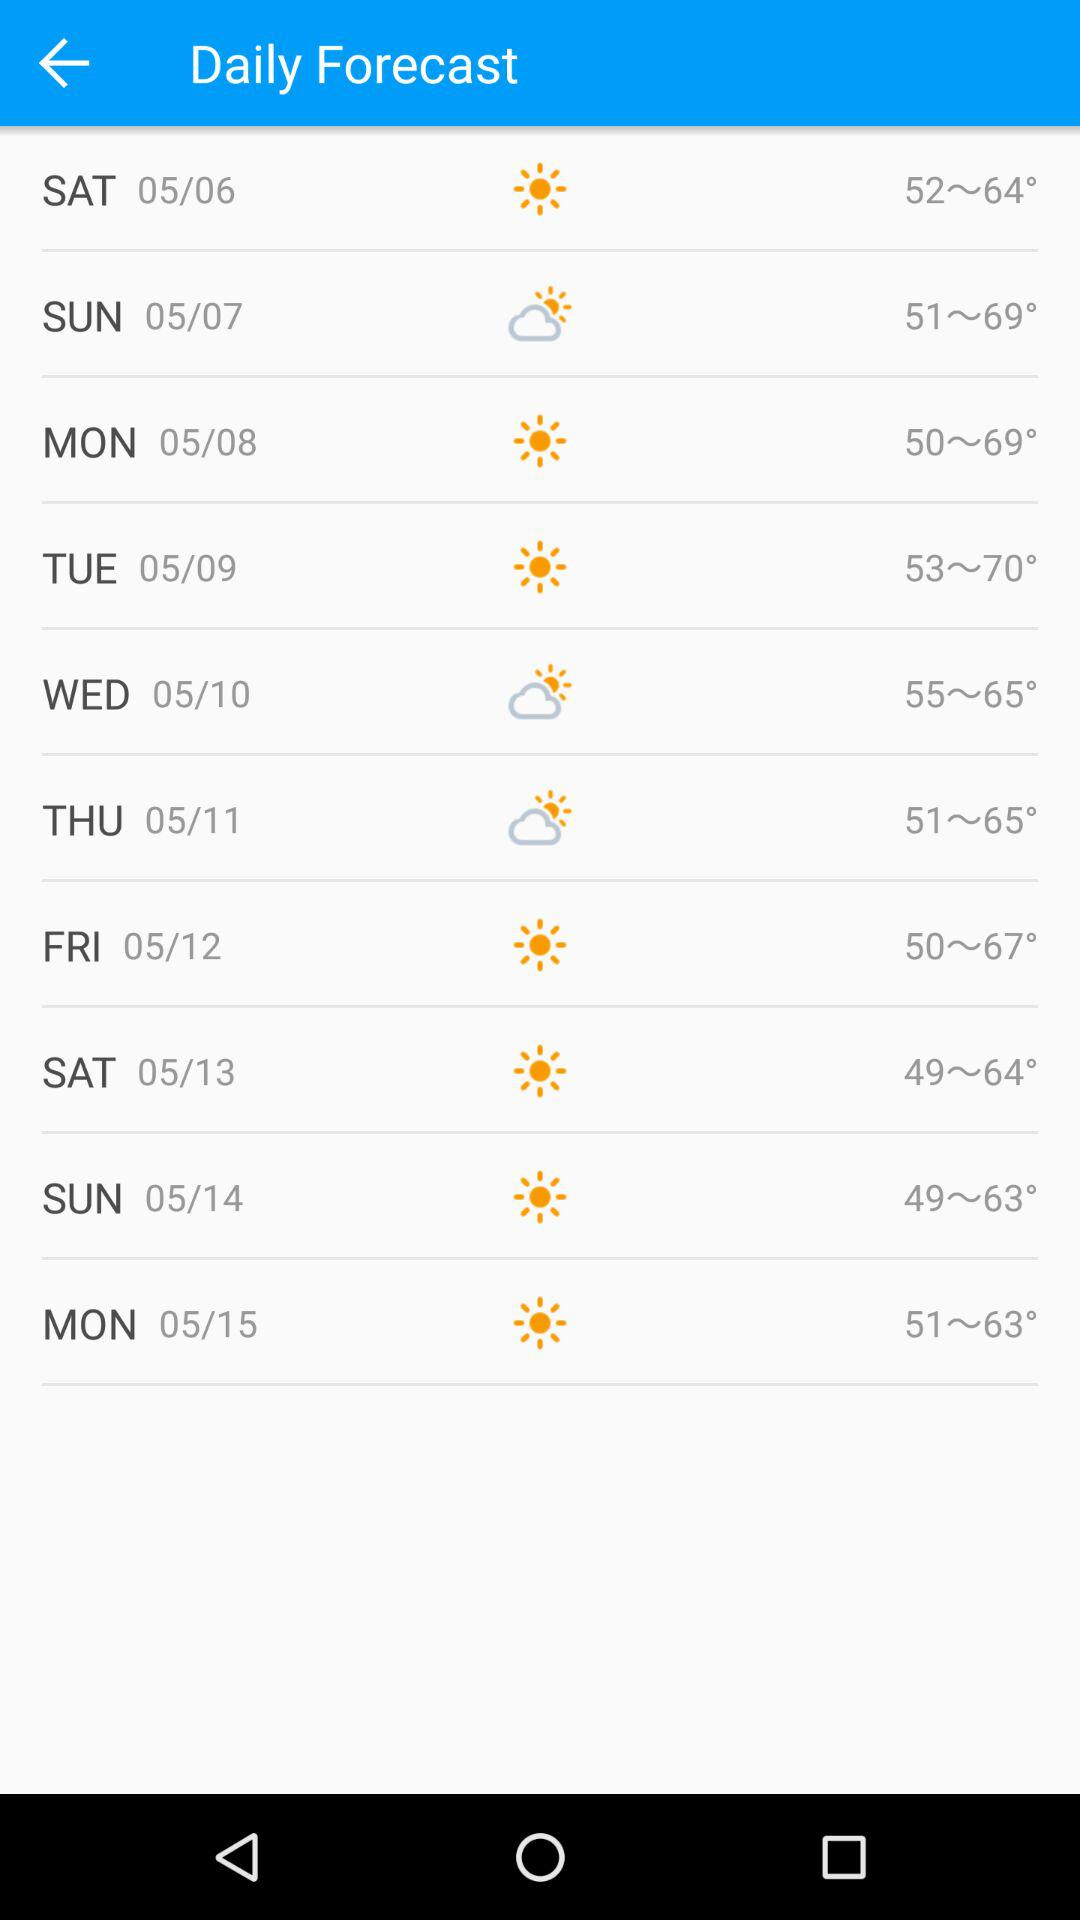What is the temperature range on Monday, May 8? The temperature range on Monday, May 8 is 50° to 69°. 